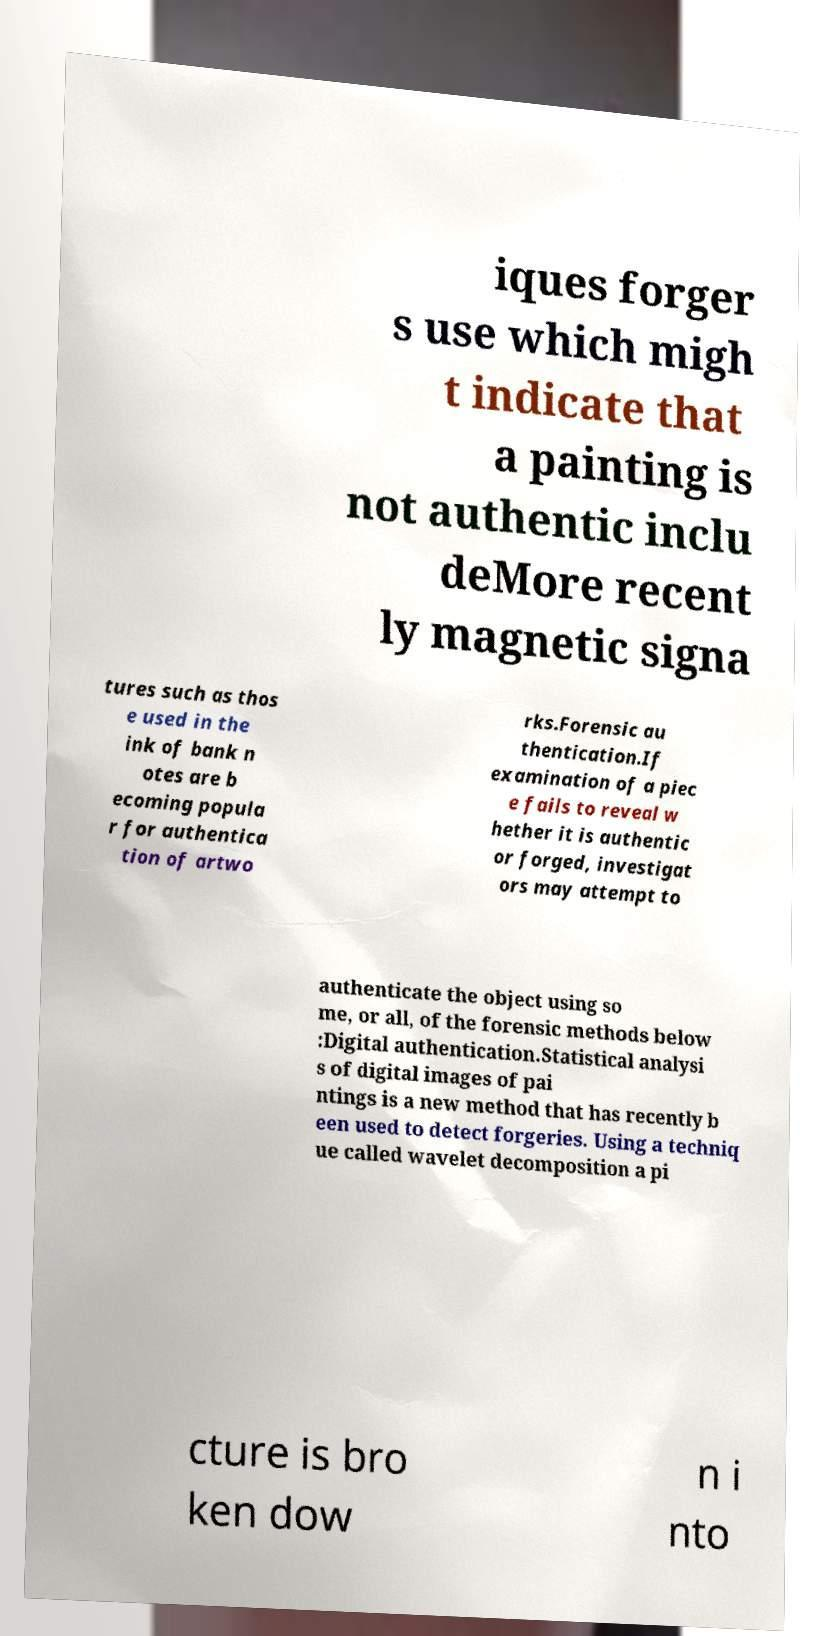Could you assist in decoding the text presented in this image and type it out clearly? iques forger s use which migh t indicate that a painting is not authentic inclu deMore recent ly magnetic signa tures such as thos e used in the ink of bank n otes are b ecoming popula r for authentica tion of artwo rks.Forensic au thentication.If examination of a piec e fails to reveal w hether it is authentic or forged, investigat ors may attempt to authenticate the object using so me, or all, of the forensic methods below :Digital authentication.Statistical analysi s of digital images of pai ntings is a new method that has recently b een used to detect forgeries. Using a techniq ue called wavelet decomposition a pi cture is bro ken dow n i nto 